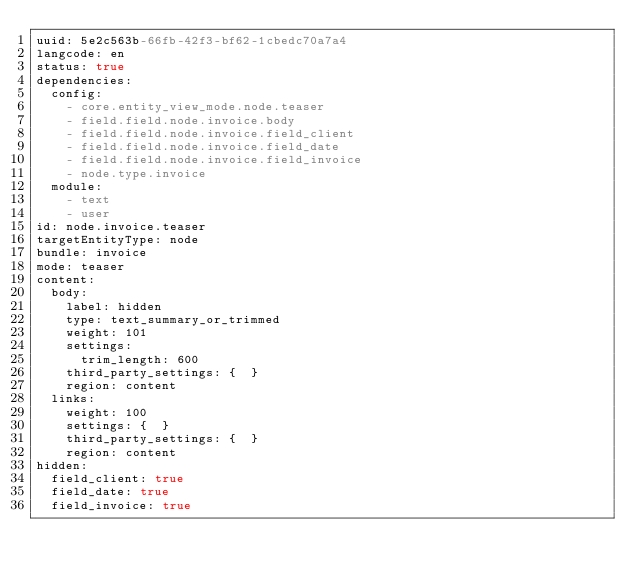<code> <loc_0><loc_0><loc_500><loc_500><_YAML_>uuid: 5e2c563b-66fb-42f3-bf62-1cbedc70a7a4
langcode: en
status: true
dependencies:
  config:
    - core.entity_view_mode.node.teaser
    - field.field.node.invoice.body
    - field.field.node.invoice.field_client
    - field.field.node.invoice.field_date
    - field.field.node.invoice.field_invoice
    - node.type.invoice
  module:
    - text
    - user
id: node.invoice.teaser
targetEntityType: node
bundle: invoice
mode: teaser
content:
  body:
    label: hidden
    type: text_summary_or_trimmed
    weight: 101
    settings:
      trim_length: 600
    third_party_settings: {  }
    region: content
  links:
    weight: 100
    settings: {  }
    third_party_settings: {  }
    region: content
hidden:
  field_client: true
  field_date: true
  field_invoice: true
</code> 